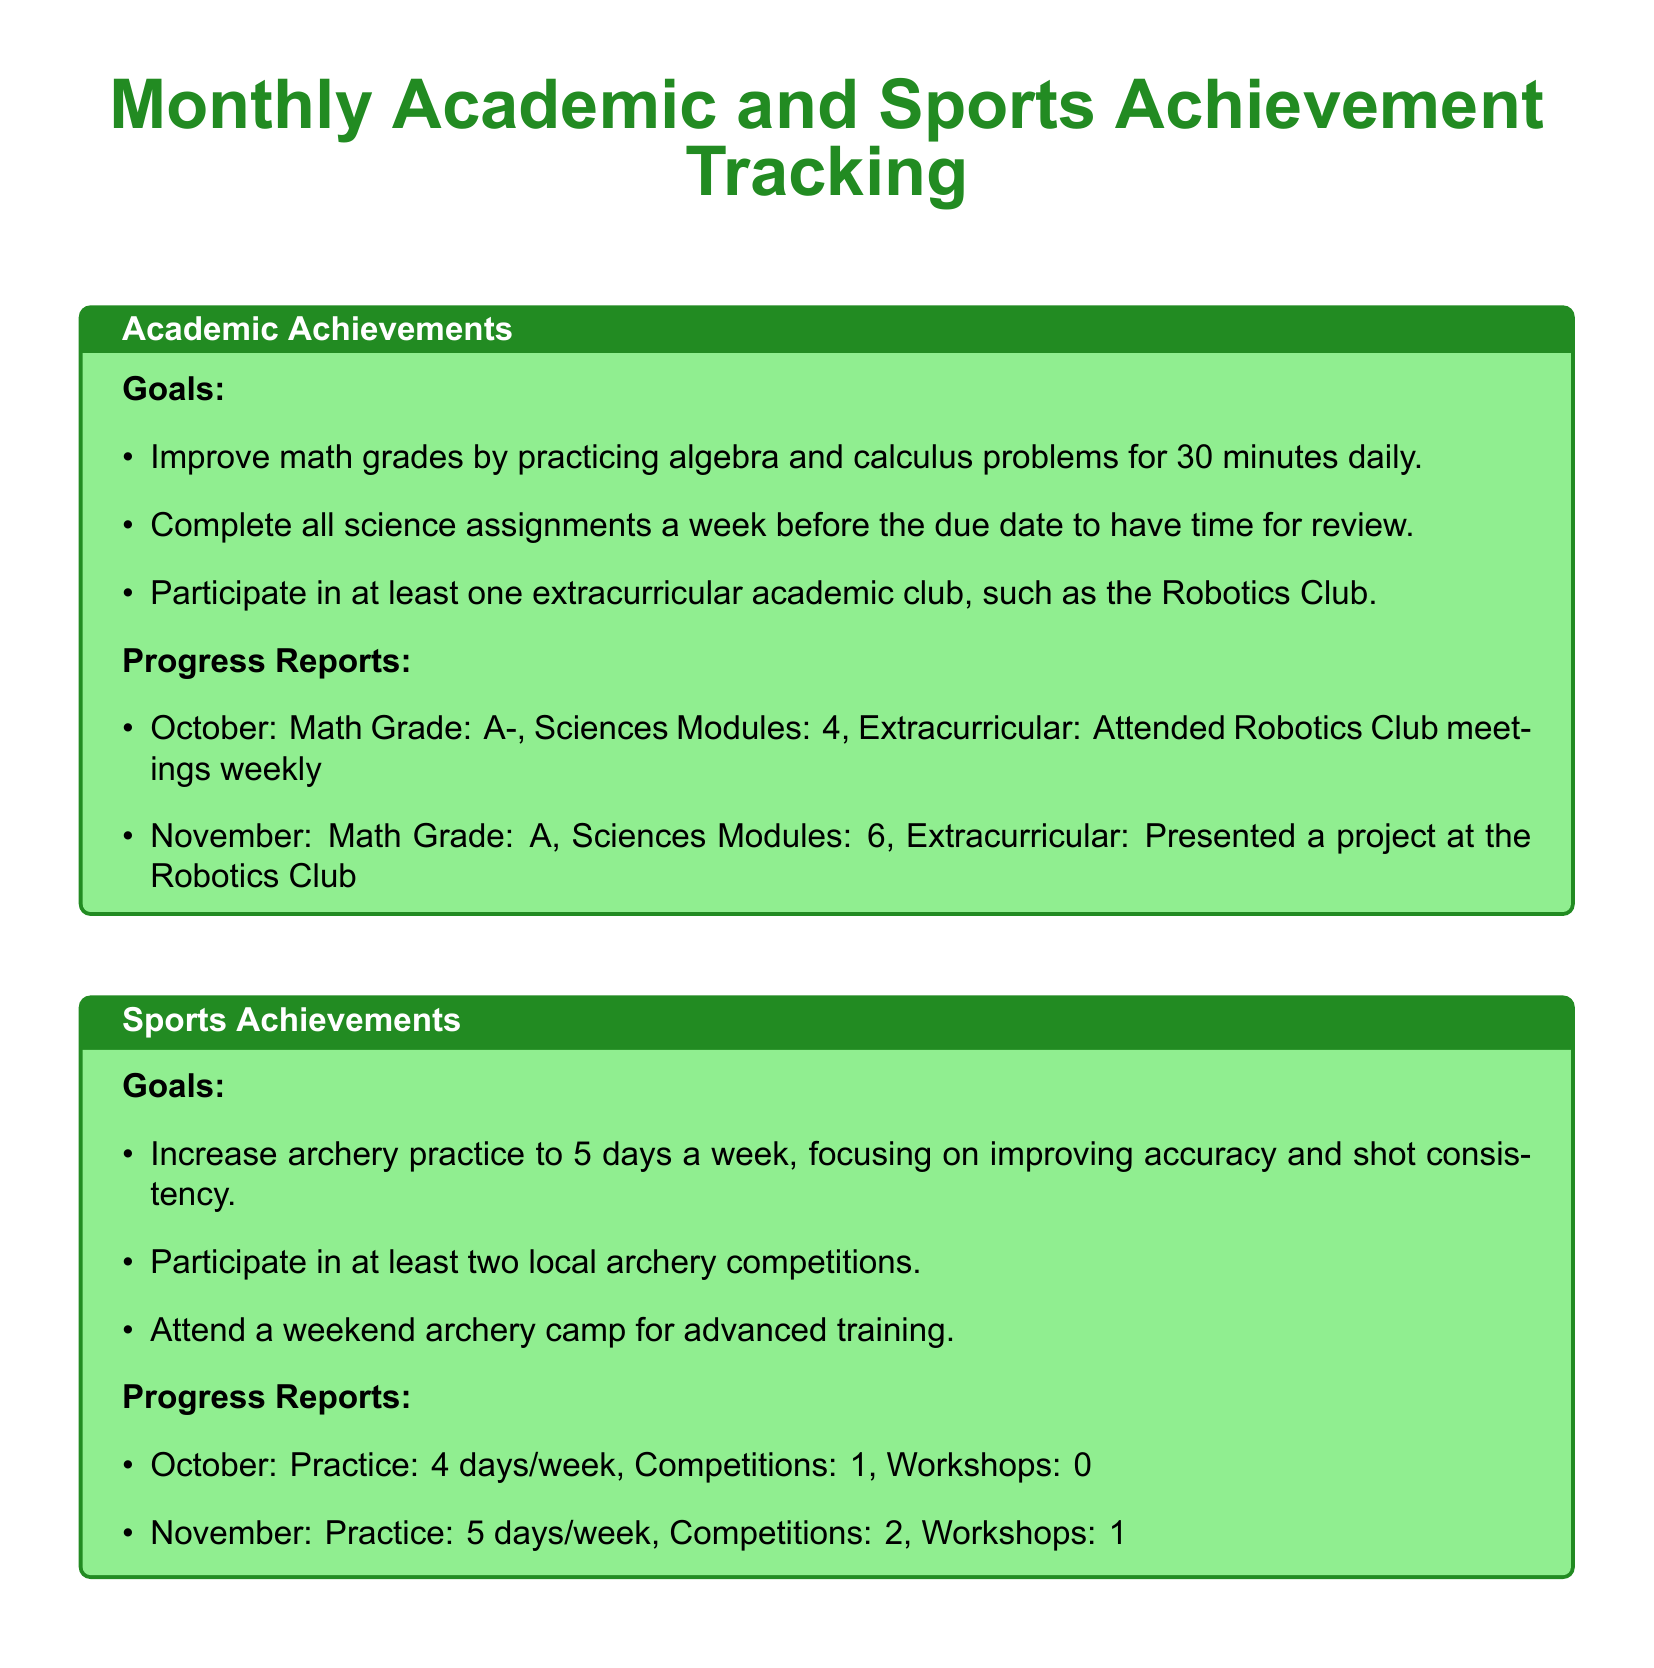What were the academic goals for improvement? The goals for improvement in academics include practicing algebra and calculus problems for 30 minutes daily, completing all science assignments a week before the due date, and participating in at least one extracurricular academic club.
Answer: Improve math grades, complete science assignments, extracurricular club participation What was the math grade in November? The document states that the math grade in November was A.
Answer: A How many days a week was archery practiced in October? According to the progress report, archery practice was 4 days a week in October.
Answer: 4 days/week What is one area for improvement listed in the summary? The summary mentions continuing active involvement in the Robotics Club as one area for improvement.
Answer: Active involvement in Robotics Club What achievement was highlighted for November in sports? The document highlights that in November, winning 1st place in a local archery competition was an achievement.
Answer: 1st place in a local archery competition How many local archery competitions were participated in during November? The document indicates participation in 2 local archery competitions in November.
Answer: 2 What was the improvement in the math grade from October to November? The document states that the math grade improved from A- in October to A in November.
Answer: Improved from A- to A How many science modules were completed in November? The progress report lists 6 science modules completed in November.
Answer: 6 